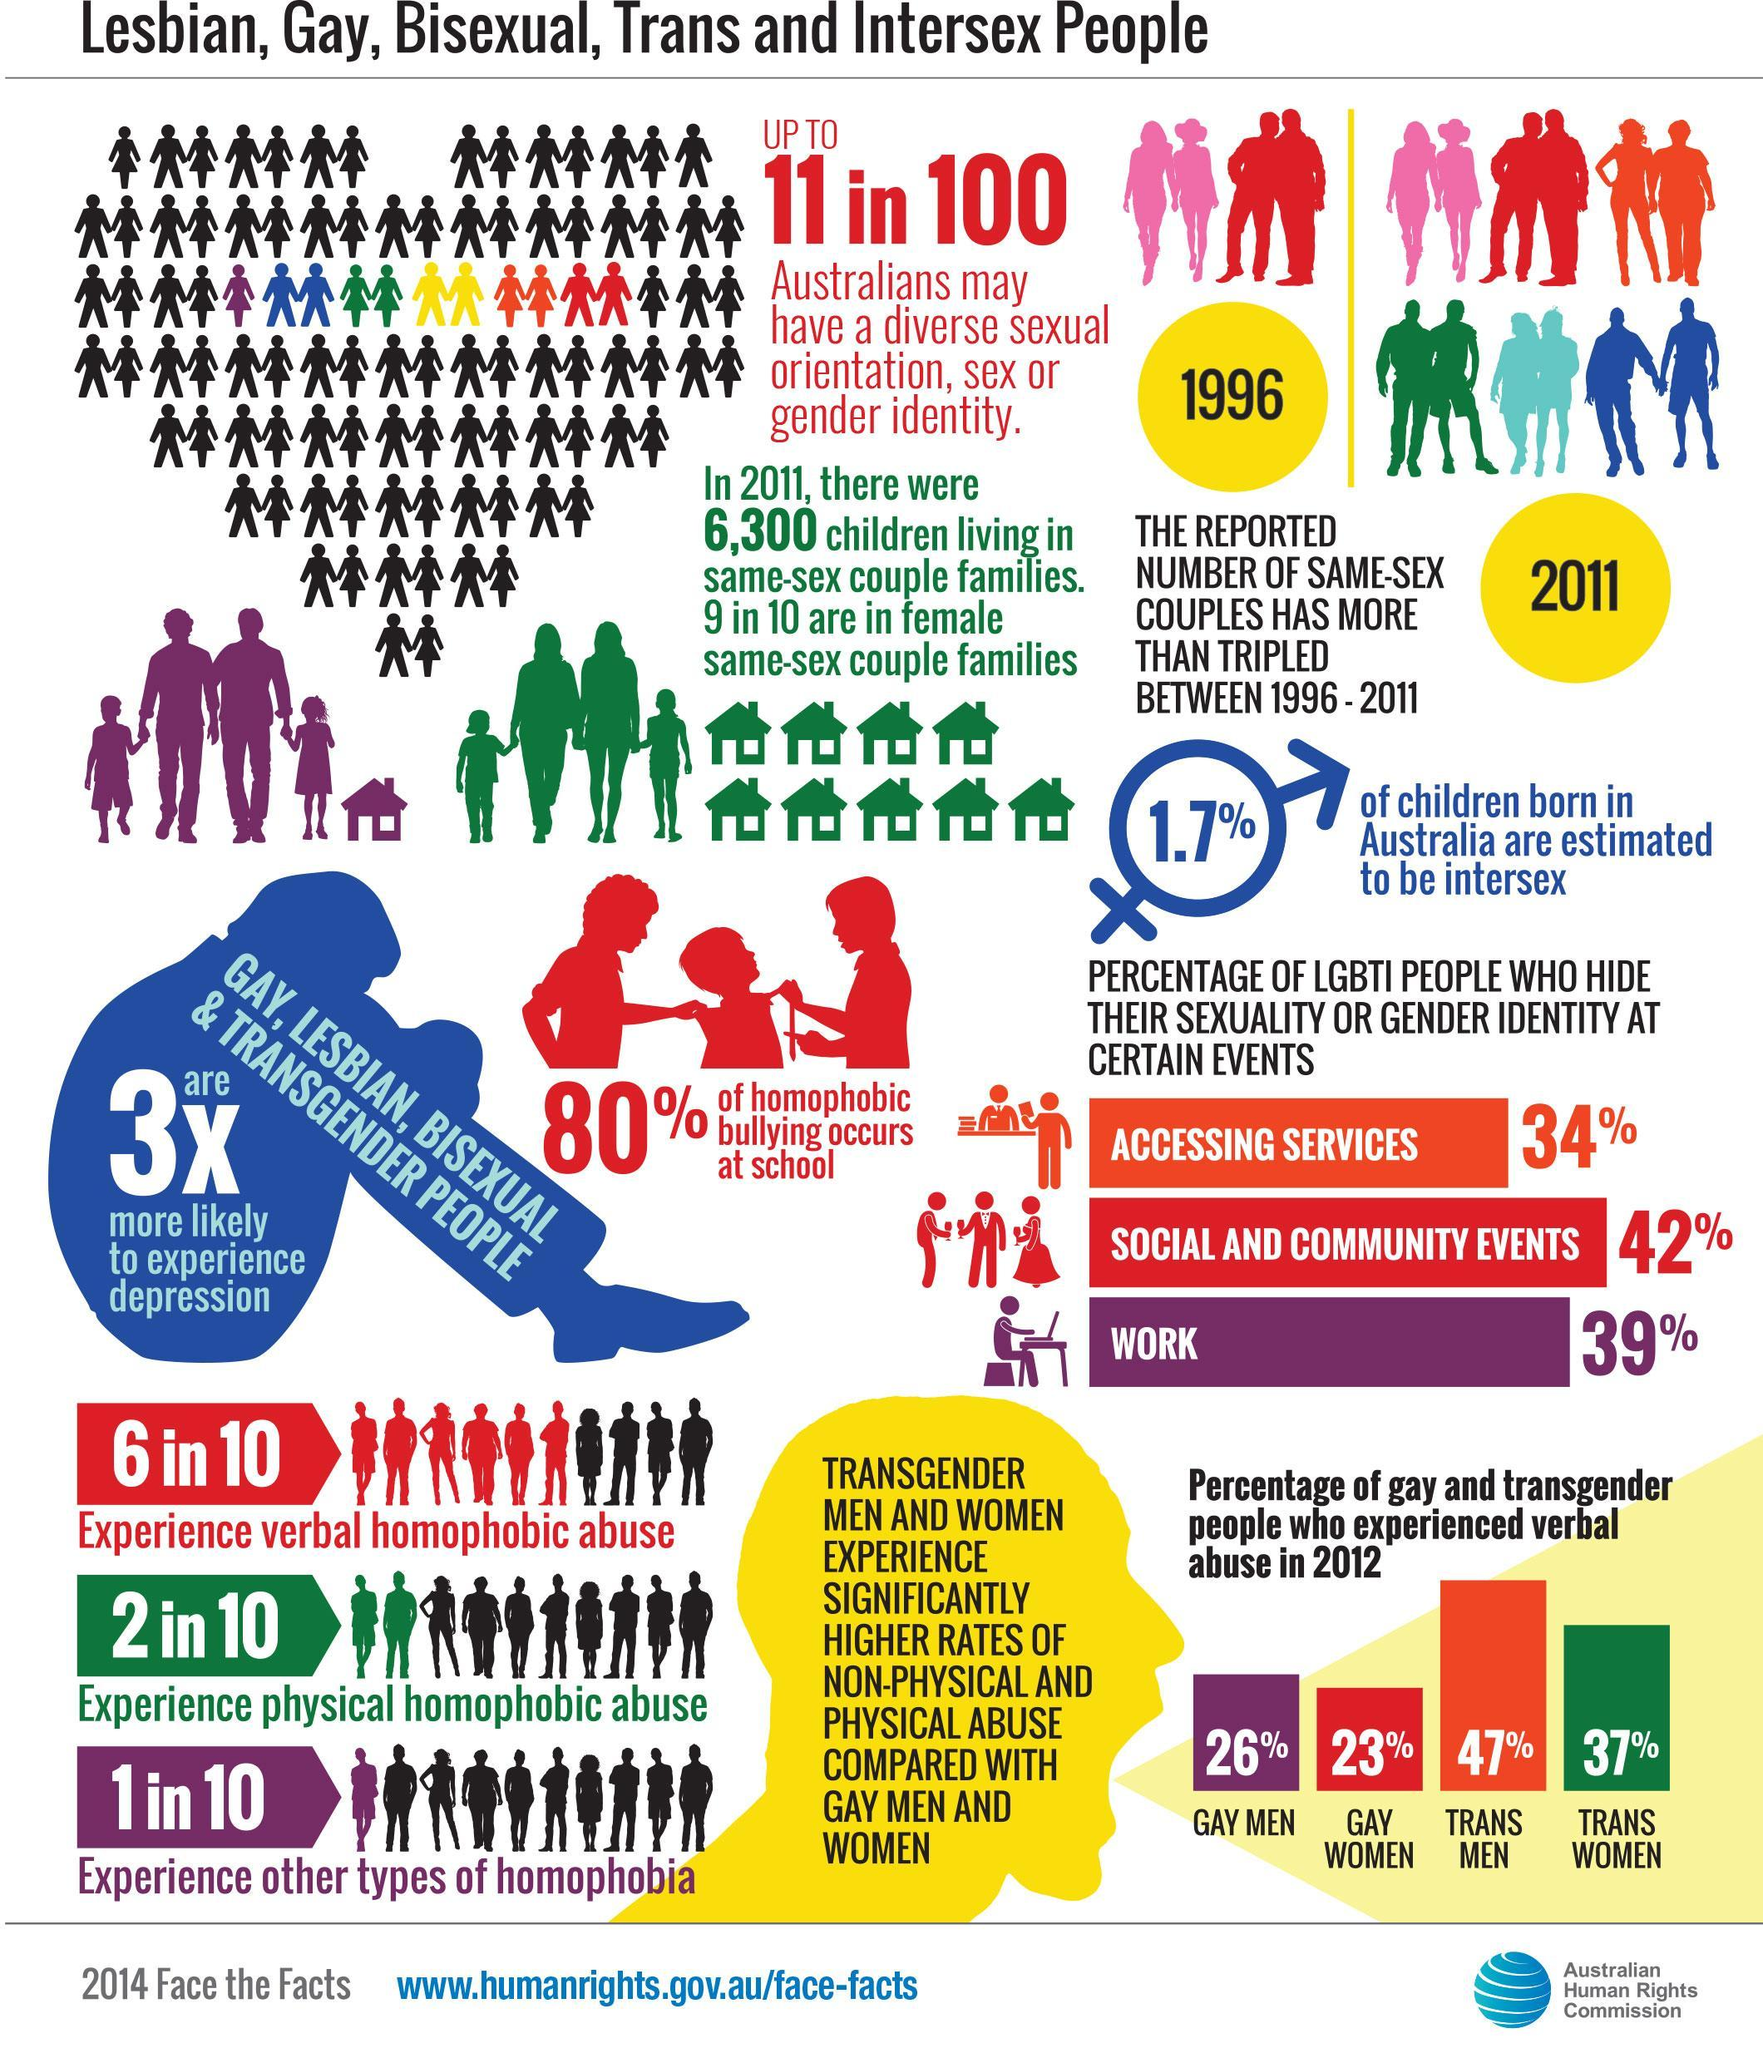Which group of LGBTI people experienced verbal abuse the second most in 2012?
Answer the question with a short phrase. Trans women In Which event do LGBTI people hide their sexuality the second most? work What percent of LGBTI people experience verbal homophobic abuse? 60% What percent of LGBTI people experience other types of homophobia? 10% Which group of LGBTI people experienced verbal abuse the third most in 2012? gay men What percentage of 6300 children are in female same-sex couple families in 2011? 90% In Which event do LGBTI people hide their sexuality the most? Social and community events What percent of LGBTI people experience physical homophobic abuse? 20% Which group of LGBTI people experienced verbal abuse the most in 2012? Trans men What percent of Australians may have a diverse sexual orientation, sex or gender identity? 11% 